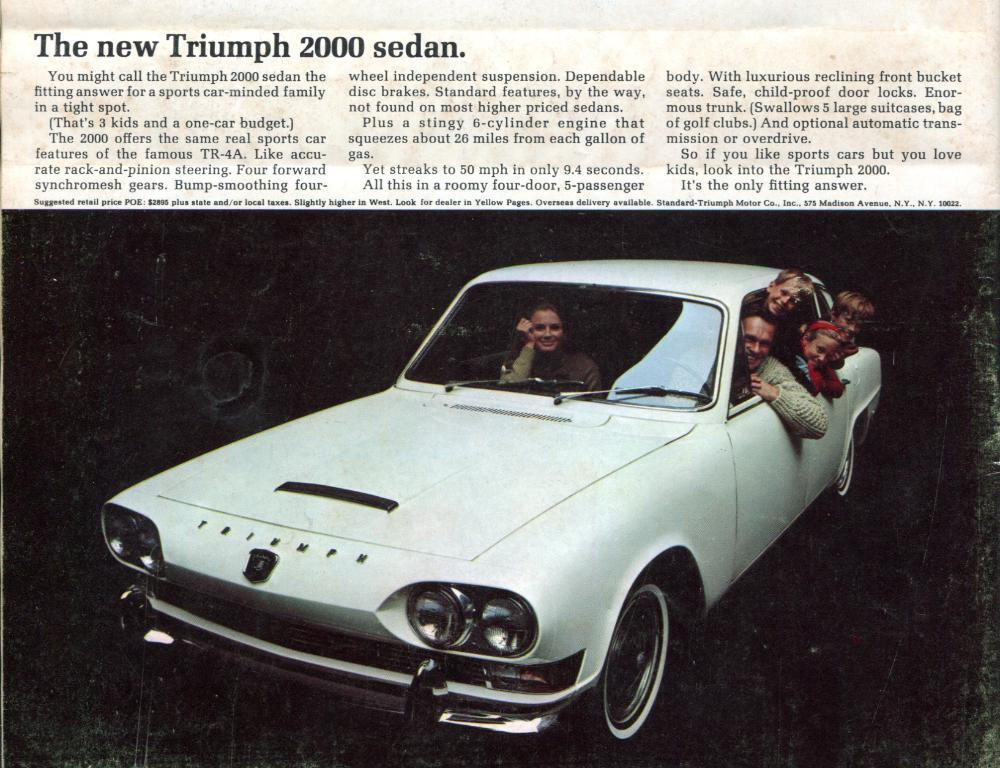What color is the car in the image? The car in the image is white. Who or what is inside the car? There are people sitting inside the car. What color is the background of the image? The background of the image is black. What can be seen written on the background? There is something written on the background. Can you see the car biting into the field in the image? No, there is no car biting into a field in the image. 